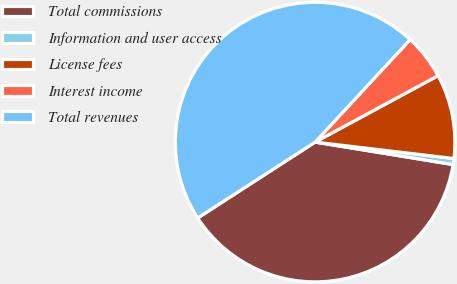<chart> <loc_0><loc_0><loc_500><loc_500><pie_chart><fcel>Total commissions<fcel>Information and user access<fcel>License fees<fcel>Interest income<fcel>Total revenues<nl><fcel>38.3%<fcel>0.69%<fcel>9.76%<fcel>5.22%<fcel>46.03%<nl></chart> 